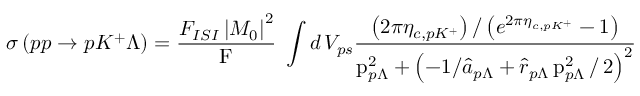Convert formula to latex. <formula><loc_0><loc_0><loc_500><loc_500>\sigma \left ( p p \rightarrow p K ^ { + } \Lambda \right ) = \frac { F _ { I S I } \left | M _ { 0 } \right | ^ { 2 } } { F } \, \int d \, V _ { p s } \frac { \left ( 2 \pi \eta _ { c , p K ^ { + } } \right ) / \left ( e ^ { 2 \pi \eta _ { c , p K ^ { + } } } - 1 \right ) } { p _ { p \Lambda } ^ { 2 } + \left ( - 1 / \hat { a } _ { p \Lambda } + \hat { r } _ { p \Lambda } \, p _ { p \Lambda } ^ { 2 } \, / \, 2 \right ) ^ { 2 } }</formula> 